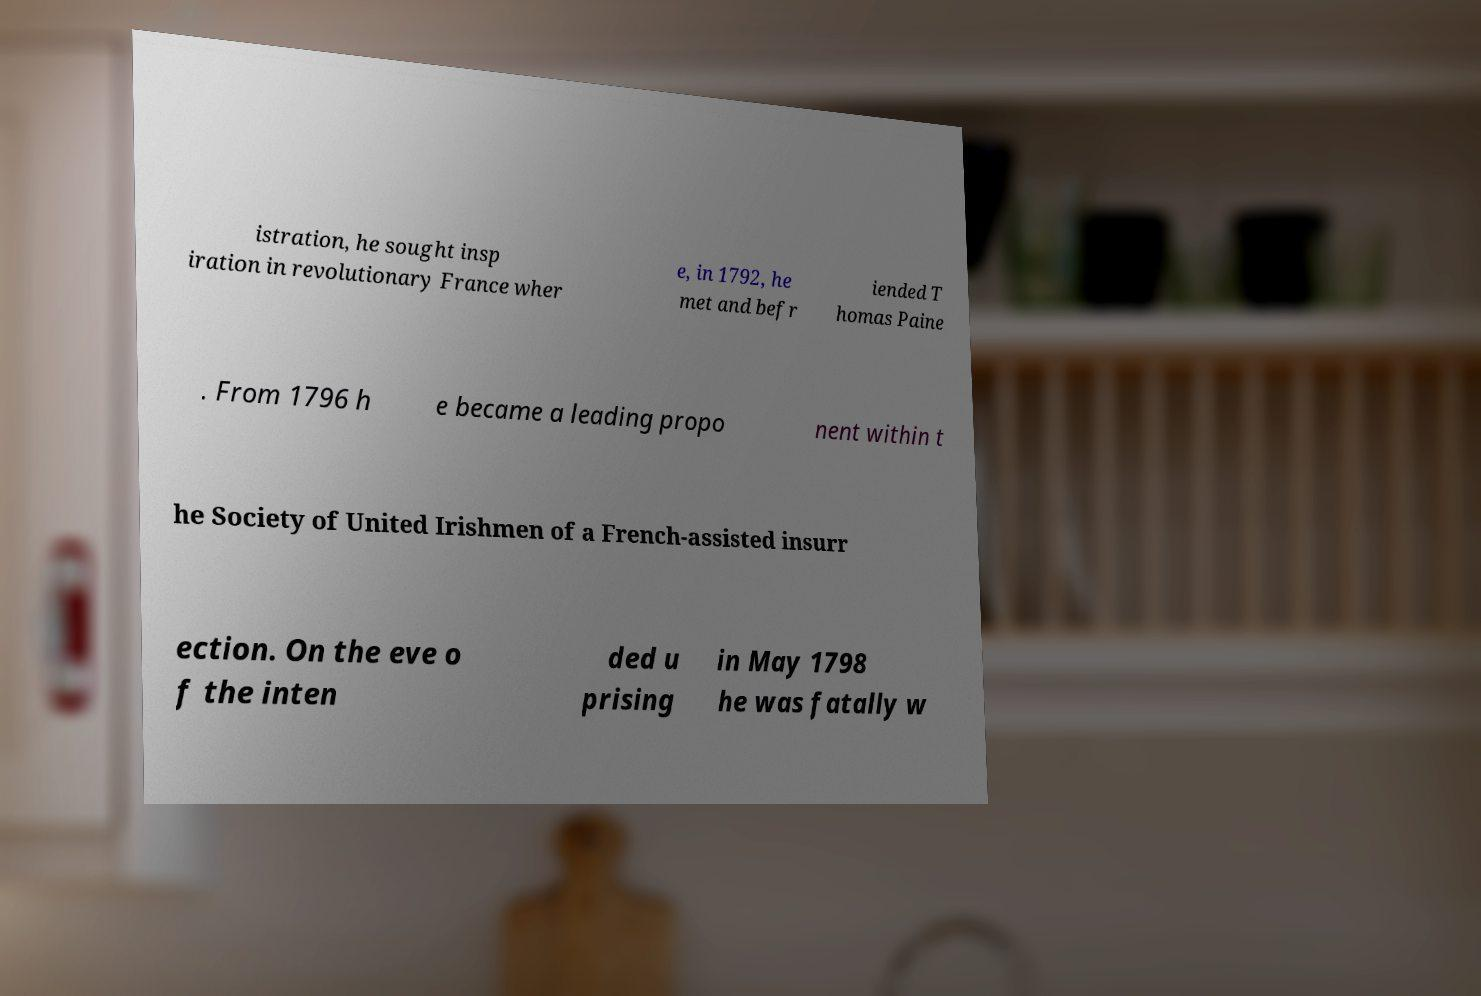Could you extract and type out the text from this image? istration, he sought insp iration in revolutionary France wher e, in 1792, he met and befr iended T homas Paine . From 1796 h e became a leading propo nent within t he Society of United Irishmen of a French-assisted insurr ection. On the eve o f the inten ded u prising in May 1798 he was fatally w 